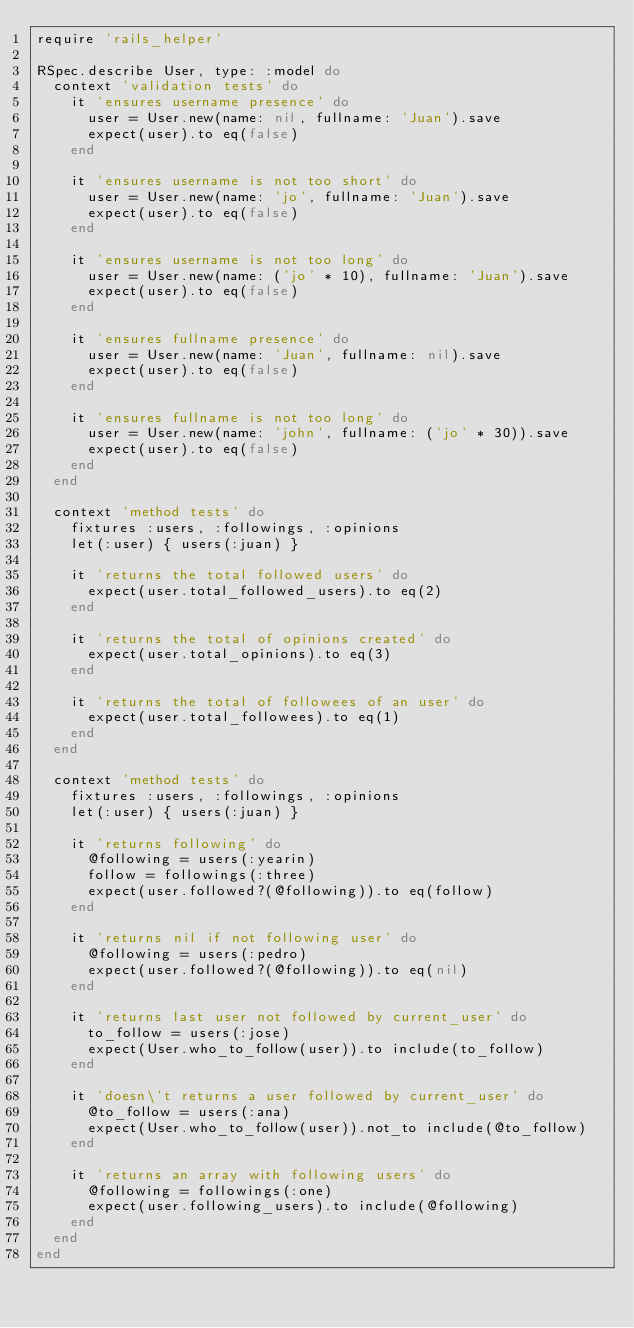<code> <loc_0><loc_0><loc_500><loc_500><_Ruby_>require 'rails_helper'

RSpec.describe User, type: :model do
  context 'validation tests' do
    it 'ensures username presence' do
      user = User.new(name: nil, fullname: 'Juan').save
      expect(user).to eq(false)
    end

    it 'ensures username is not too short' do
      user = User.new(name: 'jo', fullname: 'Juan').save
      expect(user).to eq(false)
    end

    it 'ensures username is not too long' do
      user = User.new(name: ('jo' * 10), fullname: 'Juan').save
      expect(user).to eq(false)
    end

    it 'ensures fullname presence' do
      user = User.new(name: 'Juan', fullname: nil).save
      expect(user).to eq(false)
    end

    it 'ensures fullname is not too long' do
      user = User.new(name: 'john', fullname: ('jo' * 30)).save
      expect(user).to eq(false)
    end
  end

  context 'method tests' do
    fixtures :users, :followings, :opinions
    let(:user) { users(:juan) }

    it 'returns the total followed users' do
      expect(user.total_followed_users).to eq(2)
    end

    it 'returns the total of opinions created' do
      expect(user.total_opinions).to eq(3)
    end

    it 'returns the total of followees of an user' do
      expect(user.total_followees).to eq(1)
    end
  end

  context 'method tests' do
    fixtures :users, :followings, :opinions
    let(:user) { users(:juan) }

    it 'returns following' do
      @following = users(:yearin)
      follow = followings(:three)
      expect(user.followed?(@following)).to eq(follow)
    end

    it 'returns nil if not following user' do
      @following = users(:pedro)
      expect(user.followed?(@following)).to eq(nil)
    end

    it 'returns last user not followed by current_user' do
      to_follow = users(:jose)
      expect(User.who_to_follow(user)).to include(to_follow)
    end

    it 'doesn\'t returns a user followed by current_user' do
      @to_follow = users(:ana)
      expect(User.who_to_follow(user)).not_to include(@to_follow)
    end

    it 'returns an array with following users' do
      @following = followings(:one)
      expect(user.following_users).to include(@following)
    end
  end
end
</code> 